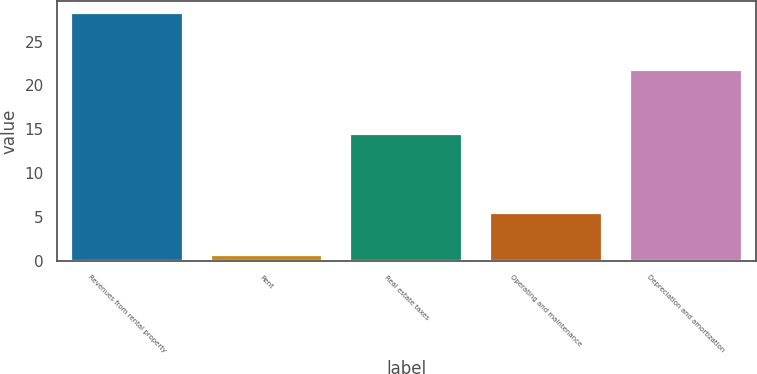Convert chart. <chart><loc_0><loc_0><loc_500><loc_500><bar_chart><fcel>Revenues from rental property<fcel>Rent<fcel>Real estate taxes<fcel>Operating and maintenance<fcel>Depreciation and amortization<nl><fcel>28.2<fcel>0.7<fcel>14.4<fcel>5.4<fcel>21.7<nl></chart> 